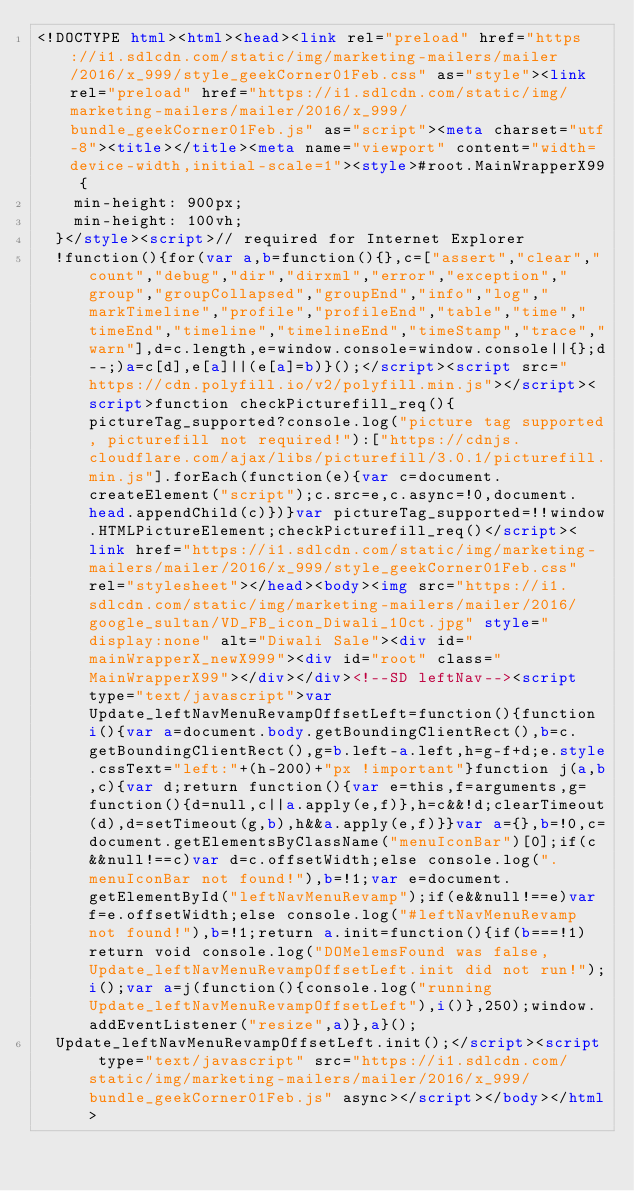<code> <loc_0><loc_0><loc_500><loc_500><_HTML_><!DOCTYPE html><html><head><link rel="preload" href="https://i1.sdlcdn.com/static/img/marketing-mailers/mailer/2016/x_999/style_geekCorner01Feb.css" as="style"><link rel="preload" href="https://i1.sdlcdn.com/static/img/marketing-mailers/mailer/2016/x_999/bundle_geekCorner01Feb.js" as="script"><meta charset="utf-8"><title></title><meta name="viewport" content="width=device-width,initial-scale=1"><style>#root.MainWrapperX99 {
	  min-height: 900px;
	  min-height: 100vh;
	}</style><script>// required for Internet Explorer
  !function(){for(var a,b=function(){},c=["assert","clear","count","debug","dir","dirxml","error","exception","group","groupCollapsed","groupEnd","info","log","markTimeline","profile","profileEnd","table","time","timeEnd","timeline","timelineEnd","timeStamp","trace","warn"],d=c.length,e=window.console=window.console||{};d--;)a=c[d],e[a]||(e[a]=b)}();</script><script src="https://cdn.polyfill.io/v2/polyfill.min.js"></script><script>function checkPicturefill_req(){pictureTag_supported?console.log("picture tag supported, picturefill not required!"):["https://cdnjs.cloudflare.com/ajax/libs/picturefill/3.0.1/picturefill.min.js"].forEach(function(e){var c=document.createElement("script");c.src=e,c.async=!0,document.head.appendChild(c)})}var pictureTag_supported=!!window.HTMLPictureElement;checkPicturefill_req()</script><link href="https://i1.sdlcdn.com/static/img/marketing-mailers/mailer/2016/x_999/style_geekCorner01Feb.css" rel="stylesheet"></head><body><img src="https://i1.sdlcdn.com/static/img/marketing-mailers/mailer/2016/google_sultan/VD_FB_icon_Diwali_1Oct.jpg" style="display:none" alt="Diwali Sale"><div id="mainWrapperX_newX999"><div id="root" class="MainWrapperX99"></div></div><!--SD leftNav--><script type="text/javascript">var Update_leftNavMenuRevampOffsetLeft=function(){function i(){var a=document.body.getBoundingClientRect(),b=c.getBoundingClientRect(),g=b.left-a.left,h=g-f+d;e.style.cssText="left:"+(h-200)+"px !important"}function j(a,b,c){var d;return function(){var e=this,f=arguments,g=function(){d=null,c||a.apply(e,f)},h=c&&!d;clearTimeout(d),d=setTimeout(g,b),h&&a.apply(e,f)}}var a={},b=!0,c=document.getElementsByClassName("menuIconBar")[0];if(c&&null!==c)var d=c.offsetWidth;else console.log(".menuIconBar not found!"),b=!1;var e=document.getElementById("leftNavMenuRevamp");if(e&&null!==e)var f=e.offsetWidth;else console.log("#leftNavMenuRevamp not found!"),b=!1;return a.init=function(){if(b===!1)return void console.log("DOMelemsFound was false, Update_leftNavMenuRevampOffsetLeft.init did not run!");i();var a=j(function(){console.log("running Update_leftNavMenuRevampOffsetLeft"),i()},250);window.addEventListener("resize",a)},a}();
	Update_leftNavMenuRevampOffsetLeft.init();</script><script type="text/javascript" src="https://i1.sdlcdn.com/static/img/marketing-mailers/mailer/2016/x_999/bundle_geekCorner01Feb.js" async></script></body></html></code> 